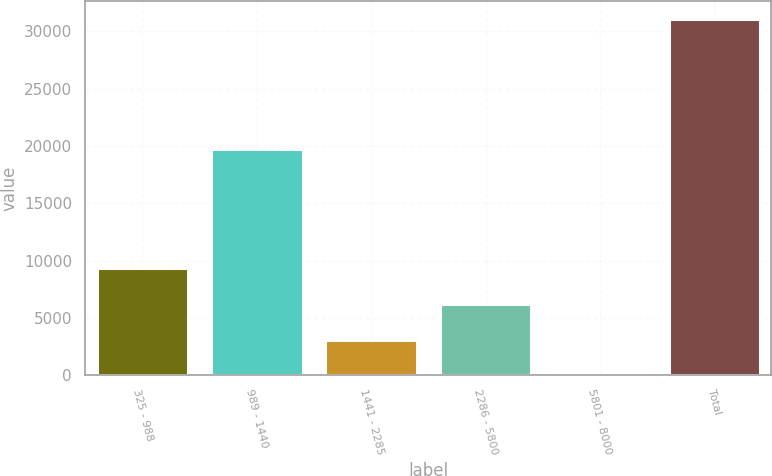Convert chart to OTSL. <chart><loc_0><loc_0><loc_500><loc_500><bar_chart><fcel>325 - 988<fcel>989 - 1440<fcel>1441 - 2285<fcel>2286 - 5800<fcel>5801 - 8000<fcel>Total<nl><fcel>9322.7<fcel>19775<fcel>3112.9<fcel>6217.8<fcel>8<fcel>31057<nl></chart> 